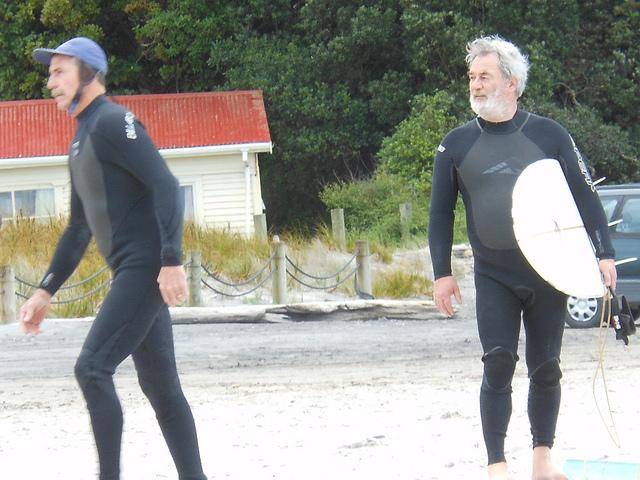Why are there two oval patterns on the right man's pants? knee pads 